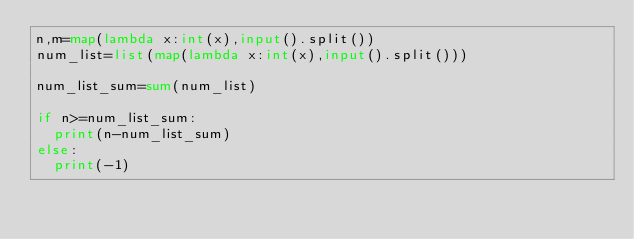<code> <loc_0><loc_0><loc_500><loc_500><_Python_>n,m=map(lambda x:int(x),input().split())
num_list=list(map(lambda x:int(x),input().split()))

num_list_sum=sum(num_list)

if n>=num_list_sum:
  print(n-num_list_sum)
else:
  print(-1)</code> 